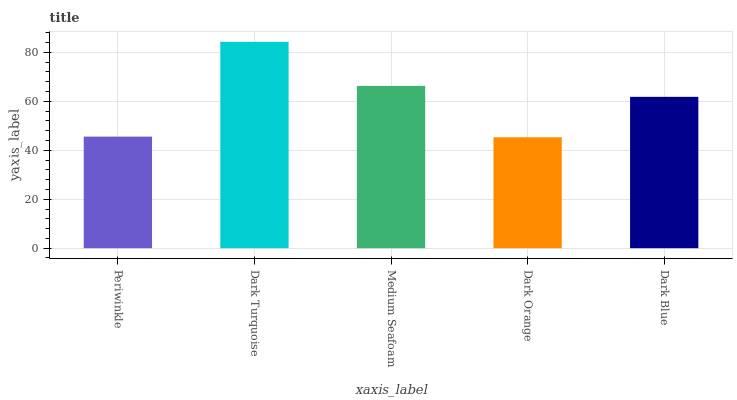Is Dark Orange the minimum?
Answer yes or no. Yes. Is Dark Turquoise the maximum?
Answer yes or no. Yes. Is Medium Seafoam the minimum?
Answer yes or no. No. Is Medium Seafoam the maximum?
Answer yes or no. No. Is Dark Turquoise greater than Medium Seafoam?
Answer yes or no. Yes. Is Medium Seafoam less than Dark Turquoise?
Answer yes or no. Yes. Is Medium Seafoam greater than Dark Turquoise?
Answer yes or no. No. Is Dark Turquoise less than Medium Seafoam?
Answer yes or no. No. Is Dark Blue the high median?
Answer yes or no. Yes. Is Dark Blue the low median?
Answer yes or no. Yes. Is Dark Turquoise the high median?
Answer yes or no. No. Is Medium Seafoam the low median?
Answer yes or no. No. 